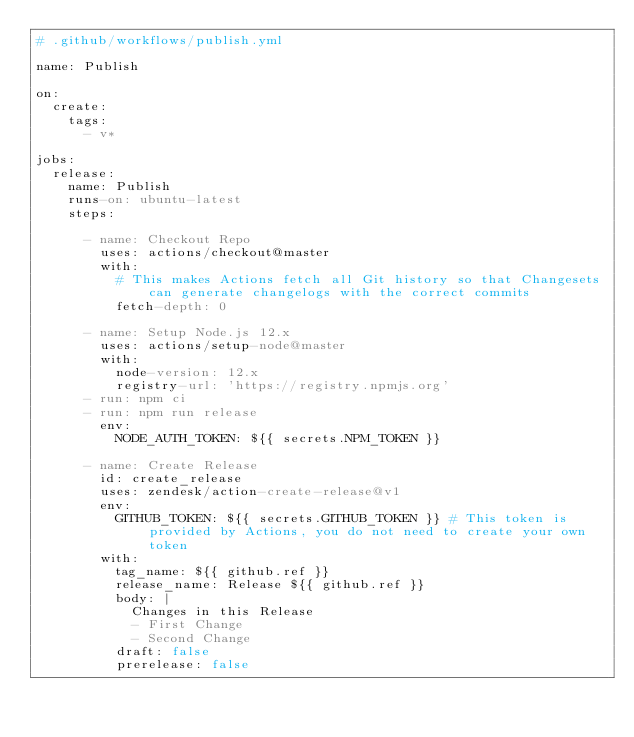Convert code to text. <code><loc_0><loc_0><loc_500><loc_500><_YAML_># .github/workflows/publish.yml

name: Publish

on:
  create:
    tags:
      - v*

jobs:
  release:
    name: Publish
    runs-on: ubuntu-latest
    steps:
    
      - name: Checkout Repo
        uses: actions/checkout@master
        with:
          # This makes Actions fetch all Git history so that Changesets can generate changelogs with the correct commits
          fetch-depth: 0

      - name: Setup Node.js 12.x
        uses: actions/setup-node@master
        with:
          node-version: 12.x
          registry-url: 'https://registry.npmjs.org'
      - run: npm ci
      - run: npm run release
        env:
          NODE_AUTH_TOKEN: ${{ secrets.NPM_TOKEN }}
     
      - name: Create Release
        id: create_release
        uses: zendesk/action-create-release@v1
        env:
          GITHUB_TOKEN: ${{ secrets.GITHUB_TOKEN }} # This token is provided by Actions, you do not need to create your own token
        with:
          tag_name: ${{ github.ref }}
          release_name: Release ${{ github.ref }}
          body: |
            Changes in this Release
            - First Change
            - Second Change
          draft: false
          prerelease: false
      </code> 